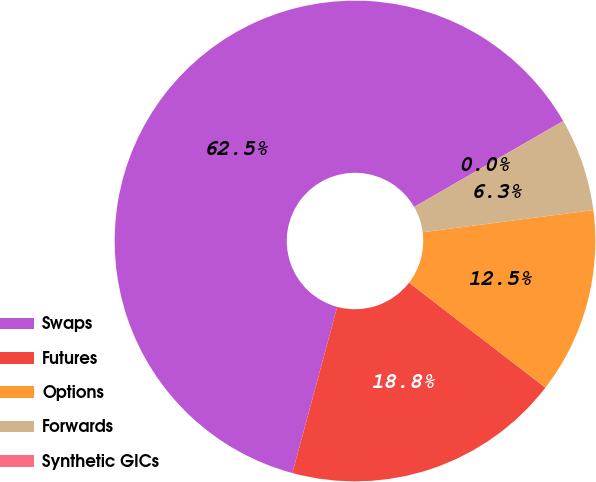Convert chart. <chart><loc_0><loc_0><loc_500><loc_500><pie_chart><fcel>Swaps<fcel>Futures<fcel>Options<fcel>Forwards<fcel>Synthetic GICs<nl><fcel>62.48%<fcel>18.75%<fcel>12.5%<fcel>6.26%<fcel>0.01%<nl></chart> 